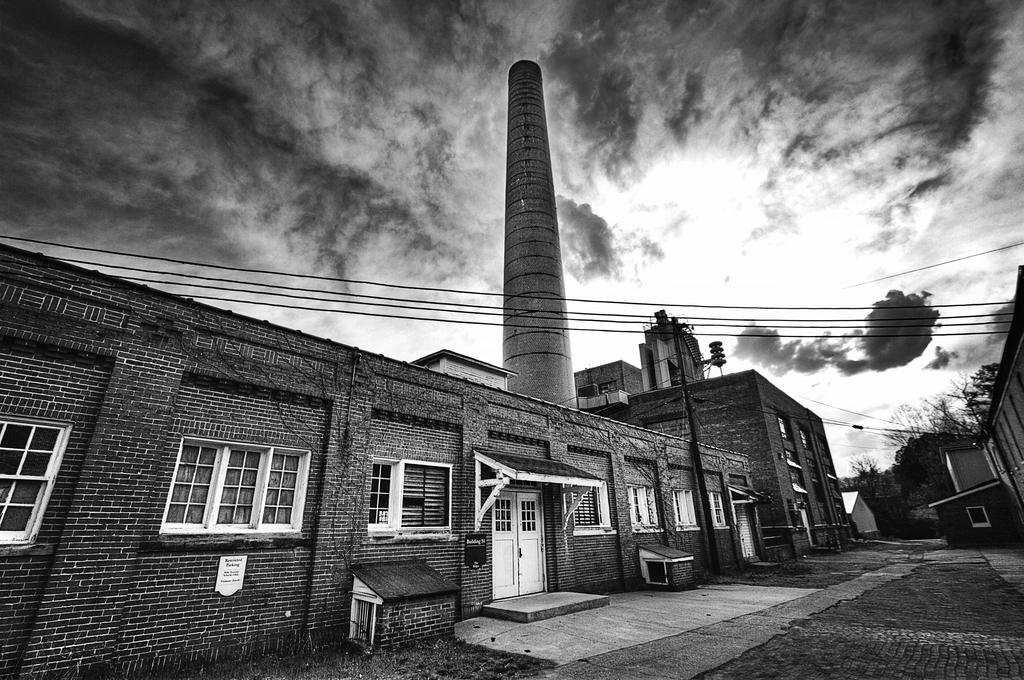What type of structures can be seen in the image? There are buildings in the image. What architectural features are present on the buildings? There are windows and doors visible on the buildings. What type of vegetation is present in the image? There is grass and trees in the image. What part of the natural environment is visible in the image? The sky is visible in the image, along with clouds. What is the fifth building in the image? There is no mention of a fifth building in the image, as the facts only mention the presence of buildings in general. 